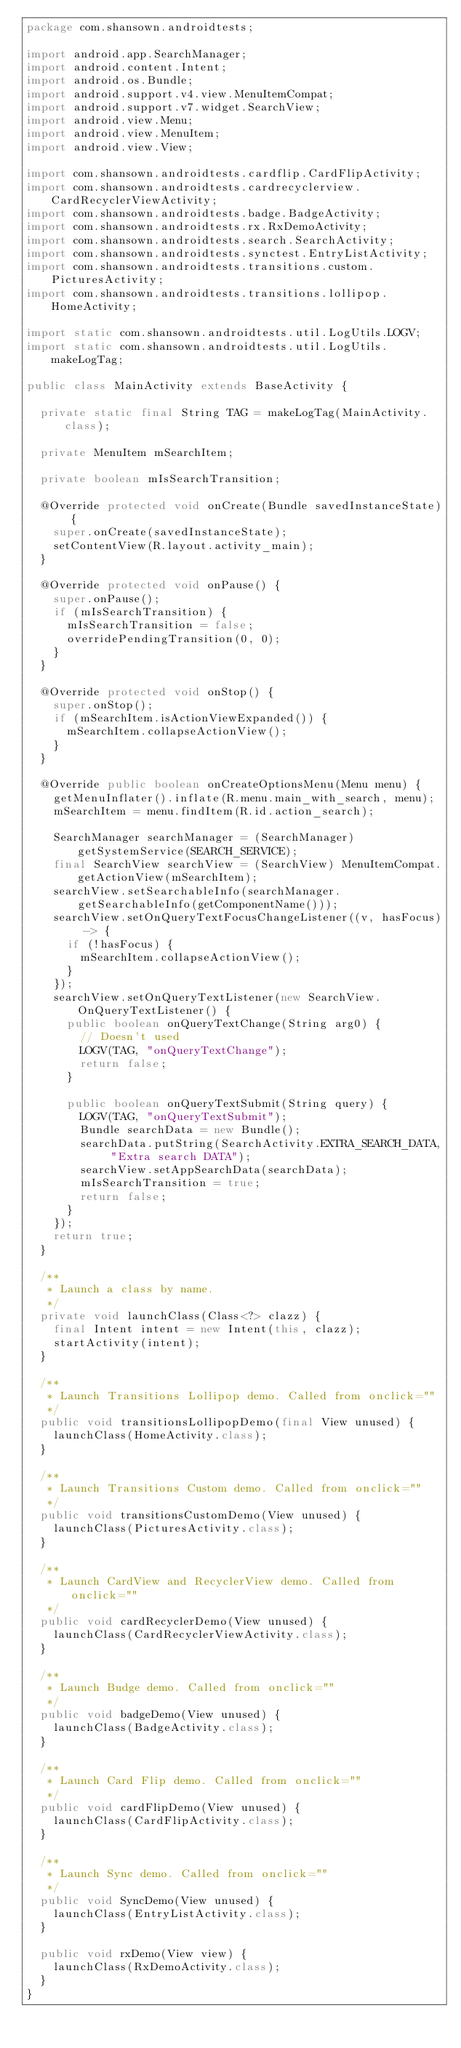Convert code to text. <code><loc_0><loc_0><loc_500><loc_500><_Java_>package com.shansown.androidtests;

import android.app.SearchManager;
import android.content.Intent;
import android.os.Bundle;
import android.support.v4.view.MenuItemCompat;
import android.support.v7.widget.SearchView;
import android.view.Menu;
import android.view.MenuItem;
import android.view.View;

import com.shansown.androidtests.cardflip.CardFlipActivity;
import com.shansown.androidtests.cardrecyclerview.CardRecyclerViewActivity;
import com.shansown.androidtests.badge.BadgeActivity;
import com.shansown.androidtests.rx.RxDemoActivity;
import com.shansown.androidtests.search.SearchActivity;
import com.shansown.androidtests.synctest.EntryListActivity;
import com.shansown.androidtests.transitions.custom.PicturesActivity;
import com.shansown.androidtests.transitions.lollipop.HomeActivity;

import static com.shansown.androidtests.util.LogUtils.LOGV;
import static com.shansown.androidtests.util.LogUtils.makeLogTag;

public class MainActivity extends BaseActivity {

  private static final String TAG = makeLogTag(MainActivity.class);

  private MenuItem mSearchItem;

  private boolean mIsSearchTransition;

  @Override protected void onCreate(Bundle savedInstanceState) {
    super.onCreate(savedInstanceState);
    setContentView(R.layout.activity_main);
  }

  @Override protected void onPause() {
    super.onPause();
    if (mIsSearchTransition) {
      mIsSearchTransition = false;
      overridePendingTransition(0, 0);
    }
  }

  @Override protected void onStop() {
    super.onStop();
    if (mSearchItem.isActionViewExpanded()) {
      mSearchItem.collapseActionView();
    }
  }

  @Override public boolean onCreateOptionsMenu(Menu menu) {
    getMenuInflater().inflate(R.menu.main_with_search, menu);
    mSearchItem = menu.findItem(R.id.action_search);

    SearchManager searchManager = (SearchManager) getSystemService(SEARCH_SERVICE);
    final SearchView searchView = (SearchView) MenuItemCompat.getActionView(mSearchItem);
    searchView.setSearchableInfo(searchManager.getSearchableInfo(getComponentName()));
    searchView.setOnQueryTextFocusChangeListener((v, hasFocus) -> {
      if (!hasFocus) {
        mSearchItem.collapseActionView();
      }
    });
    searchView.setOnQueryTextListener(new SearchView.OnQueryTextListener() {
      public boolean onQueryTextChange(String arg0) {
        // Doesn't used
        LOGV(TAG, "onQueryTextChange");
        return false;
      }

      public boolean onQueryTextSubmit(String query) {
        LOGV(TAG, "onQueryTextSubmit");
        Bundle searchData = new Bundle();
        searchData.putString(SearchActivity.EXTRA_SEARCH_DATA, "Extra search DATA");
        searchView.setAppSearchData(searchData);
        mIsSearchTransition = true;
        return false;
      }
    });
    return true;
  }

  /**
   * Launch a class by name.
   */
  private void launchClass(Class<?> clazz) {
    final Intent intent = new Intent(this, clazz);
    startActivity(intent);
  }

  /**
   * Launch Transitions Lollipop demo. Called from onclick=""
   */
  public void transitionsLollipopDemo(final View unused) {
    launchClass(HomeActivity.class);
  }

  /**
   * Launch Transitions Custom demo. Called from onclick=""
   */
  public void transitionsCustomDemo(View unused) {
    launchClass(PicturesActivity.class);
  }

  /**
   * Launch CardView and RecyclerView demo. Called from onclick=""
   */
  public void cardRecyclerDemo(View unused) {
    launchClass(CardRecyclerViewActivity.class);
  }

  /**
   * Launch Budge demo. Called from onclick=""
   */
  public void badgeDemo(View unused) {
    launchClass(BadgeActivity.class);
  }

  /**
   * Launch Card Flip demo. Called from onclick=""
   */
  public void cardFlipDemo(View unused) {
    launchClass(CardFlipActivity.class);
  }

  /**
   * Launch Sync demo. Called from onclick=""
   */
  public void SyncDemo(View unused) {
    launchClass(EntryListActivity.class);
  }

  public void rxDemo(View view) {
    launchClass(RxDemoActivity.class);
  }
}</code> 